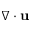Convert formula to latex. <formula><loc_0><loc_0><loc_500><loc_500>\nabla \cdot \mathbf u</formula> 